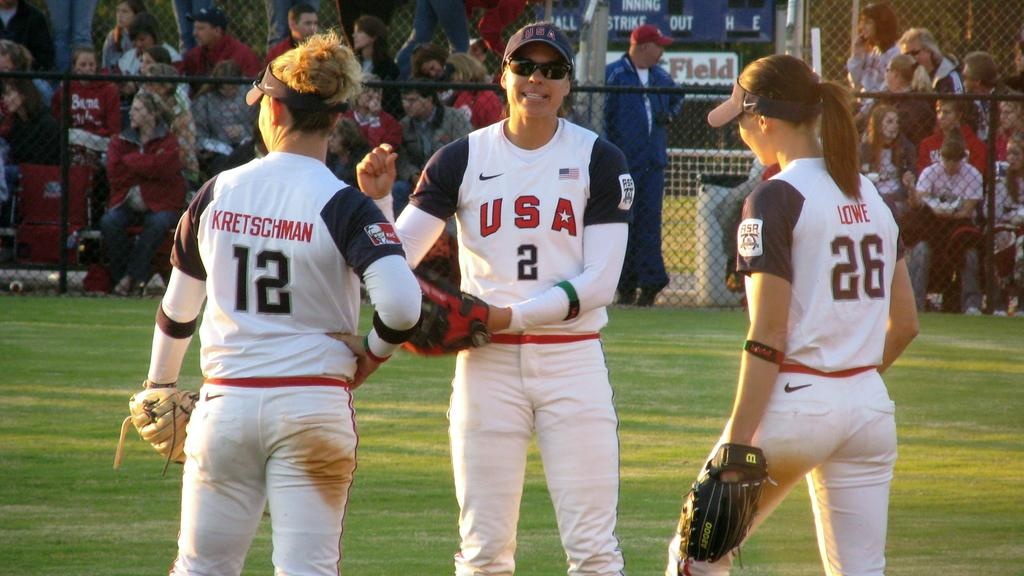<image>
Relay a brief, clear account of the picture shown. Two people wearing the number 12 and number 26 face a person wearing a jersey with the number 2. 